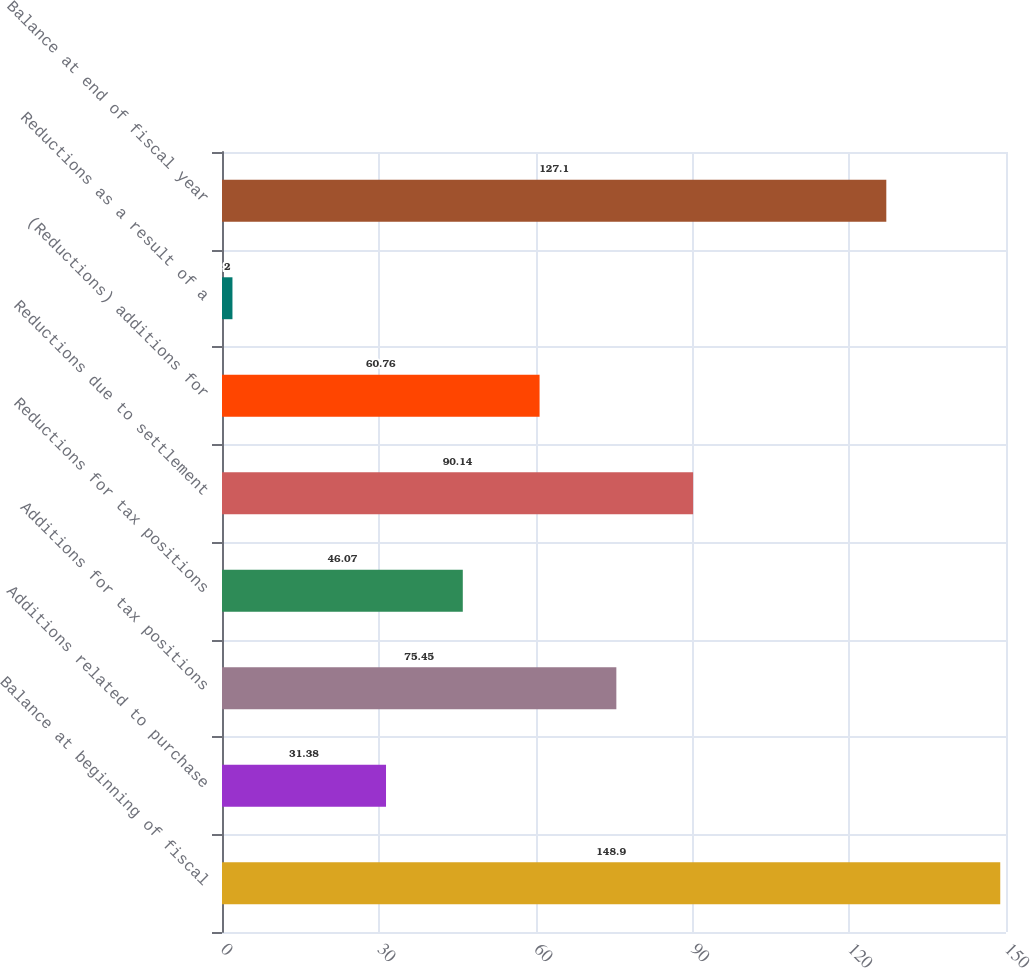Convert chart. <chart><loc_0><loc_0><loc_500><loc_500><bar_chart><fcel>Balance at beginning of fiscal<fcel>Additions related to purchase<fcel>Additions for tax positions<fcel>Reductions for tax positions<fcel>Reductions due to settlement<fcel>(Reductions) additions for<fcel>Reductions as a result of a<fcel>Balance at end of fiscal year<nl><fcel>148.9<fcel>31.38<fcel>75.45<fcel>46.07<fcel>90.14<fcel>60.76<fcel>2<fcel>127.1<nl></chart> 